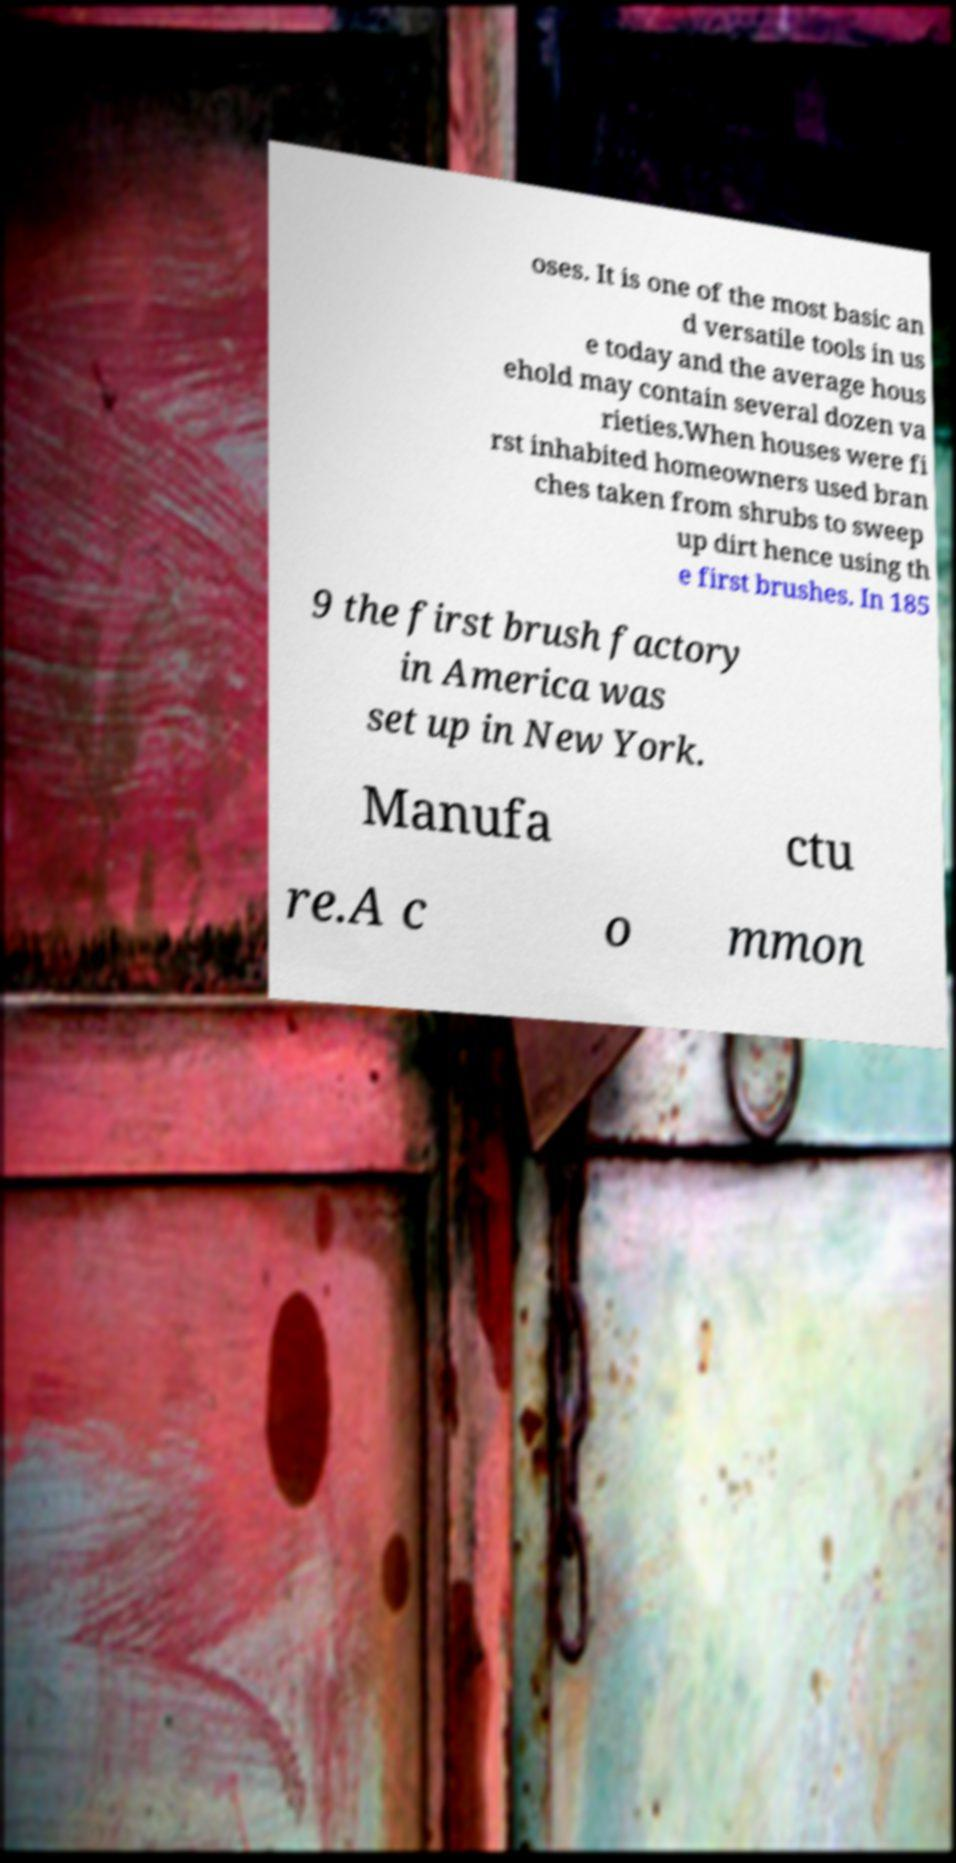Could you assist in decoding the text presented in this image and type it out clearly? oses. It is one of the most basic an d versatile tools in us e today and the average hous ehold may contain several dozen va rieties.When houses were fi rst inhabited homeowners used bran ches taken from shrubs to sweep up dirt hence using th e first brushes. In 185 9 the first brush factory in America was set up in New York. Manufa ctu re.A c o mmon 